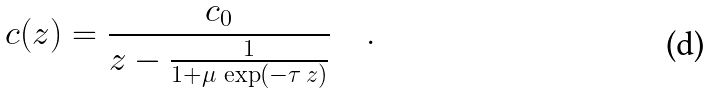Convert formula to latex. <formula><loc_0><loc_0><loc_500><loc_500>c ( z ) = \frac { c _ { 0 } } { z - \frac { 1 } { 1 + \mu \, \exp ( - \tau \, z ) } } \quad .</formula> 